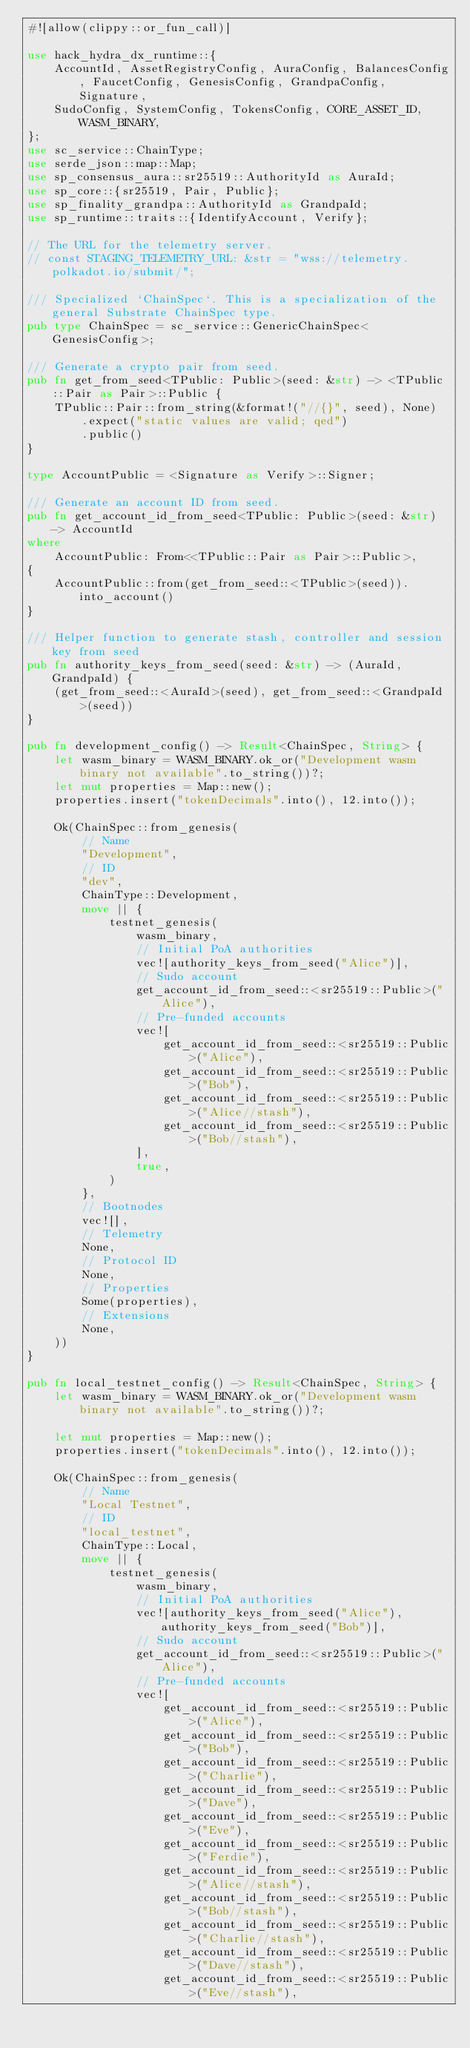Convert code to text. <code><loc_0><loc_0><loc_500><loc_500><_Rust_>#![allow(clippy::or_fun_call)]

use hack_hydra_dx_runtime::{
	AccountId, AssetRegistryConfig, AuraConfig, BalancesConfig, FaucetConfig, GenesisConfig, GrandpaConfig, Signature,
	SudoConfig, SystemConfig, TokensConfig, CORE_ASSET_ID, WASM_BINARY,
};
use sc_service::ChainType;
use serde_json::map::Map;
use sp_consensus_aura::sr25519::AuthorityId as AuraId;
use sp_core::{sr25519, Pair, Public};
use sp_finality_grandpa::AuthorityId as GrandpaId;
use sp_runtime::traits::{IdentifyAccount, Verify};

// The URL for the telemetry server.
// const STAGING_TELEMETRY_URL: &str = "wss://telemetry.polkadot.io/submit/";

/// Specialized `ChainSpec`. This is a specialization of the general Substrate ChainSpec type.
pub type ChainSpec = sc_service::GenericChainSpec<GenesisConfig>;

/// Generate a crypto pair from seed.
pub fn get_from_seed<TPublic: Public>(seed: &str) -> <TPublic::Pair as Pair>::Public {
	TPublic::Pair::from_string(&format!("//{}", seed), None)
		.expect("static values are valid; qed")
		.public()
}

type AccountPublic = <Signature as Verify>::Signer;

/// Generate an account ID from seed.
pub fn get_account_id_from_seed<TPublic: Public>(seed: &str) -> AccountId
where
	AccountPublic: From<<TPublic::Pair as Pair>::Public>,
{
	AccountPublic::from(get_from_seed::<TPublic>(seed)).into_account()
}

/// Helper function to generate stash, controller and session key from seed
pub fn authority_keys_from_seed(seed: &str) -> (AuraId, GrandpaId) {
	(get_from_seed::<AuraId>(seed), get_from_seed::<GrandpaId>(seed))
}

pub fn development_config() -> Result<ChainSpec, String> {
	let wasm_binary = WASM_BINARY.ok_or("Development wasm binary not available".to_string())?;
	let mut properties = Map::new();
	properties.insert("tokenDecimals".into(), 12.into());

	Ok(ChainSpec::from_genesis(
		// Name
		"Development",
		// ID
		"dev",
		ChainType::Development,
		move || {
			testnet_genesis(
				wasm_binary,
				// Initial PoA authorities
				vec![authority_keys_from_seed("Alice")],
				// Sudo account
				get_account_id_from_seed::<sr25519::Public>("Alice"),
				// Pre-funded accounts
				vec![
					get_account_id_from_seed::<sr25519::Public>("Alice"),
					get_account_id_from_seed::<sr25519::Public>("Bob"),
					get_account_id_from_seed::<sr25519::Public>("Alice//stash"),
					get_account_id_from_seed::<sr25519::Public>("Bob//stash"),
				],
				true,
			)
		},
		// Bootnodes
		vec![],
		// Telemetry
		None,
		// Protocol ID
		None,
		// Properties
		Some(properties),
		// Extensions
		None,
	))
}

pub fn local_testnet_config() -> Result<ChainSpec, String> {
	let wasm_binary = WASM_BINARY.ok_or("Development wasm binary not available".to_string())?;

	let mut properties = Map::new();
	properties.insert("tokenDecimals".into(), 12.into());

	Ok(ChainSpec::from_genesis(
		// Name
		"Local Testnet",
		// ID
		"local_testnet",
		ChainType::Local,
		move || {
			testnet_genesis(
				wasm_binary,
				// Initial PoA authorities
				vec![authority_keys_from_seed("Alice"), authority_keys_from_seed("Bob")],
				// Sudo account
				get_account_id_from_seed::<sr25519::Public>("Alice"),
				// Pre-funded accounts
				vec![
					get_account_id_from_seed::<sr25519::Public>("Alice"),
					get_account_id_from_seed::<sr25519::Public>("Bob"),
					get_account_id_from_seed::<sr25519::Public>("Charlie"),
					get_account_id_from_seed::<sr25519::Public>("Dave"),
					get_account_id_from_seed::<sr25519::Public>("Eve"),
					get_account_id_from_seed::<sr25519::Public>("Ferdie"),
					get_account_id_from_seed::<sr25519::Public>("Alice//stash"),
					get_account_id_from_seed::<sr25519::Public>("Bob//stash"),
					get_account_id_from_seed::<sr25519::Public>("Charlie//stash"),
					get_account_id_from_seed::<sr25519::Public>("Dave//stash"),
					get_account_id_from_seed::<sr25519::Public>("Eve//stash"),</code> 